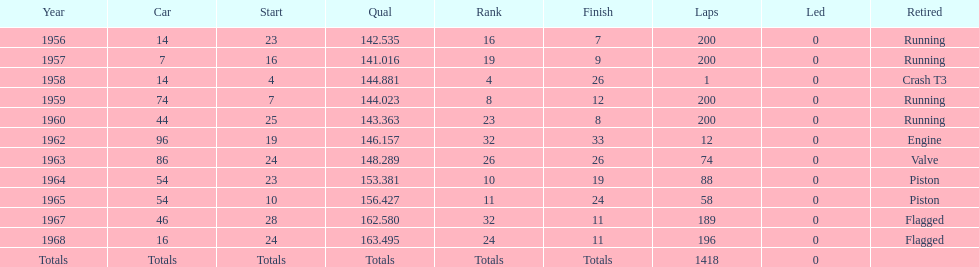Which year is the last qual on the chart 1968. 